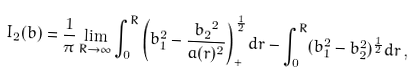<formula> <loc_0><loc_0><loc_500><loc_500>I _ { 2 } ( b ) = \frac { 1 } { \pi } \lim _ { R \rightarrow \infty } \int _ { 0 } ^ { R } \left ( b _ { 1 } ^ { 2 } - \frac { { b _ { 2 } } ^ { 2 } } { a ( r ) ^ { 2 } } \right ) _ { + } ^ { \frac { 1 } { 2 } } d r - \int _ { 0 } ^ { R } ( b _ { 1 } ^ { 2 } - b _ { 2 } ^ { 2 } ) ^ { \frac { 1 } { 2 } } d r \, ,</formula> 